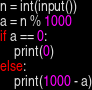Convert code to text. <code><loc_0><loc_0><loc_500><loc_500><_Python_>n = int(input())
a = n % 1000
if a == 0:
    print(0)
else:
    print(1000 - a)</code> 